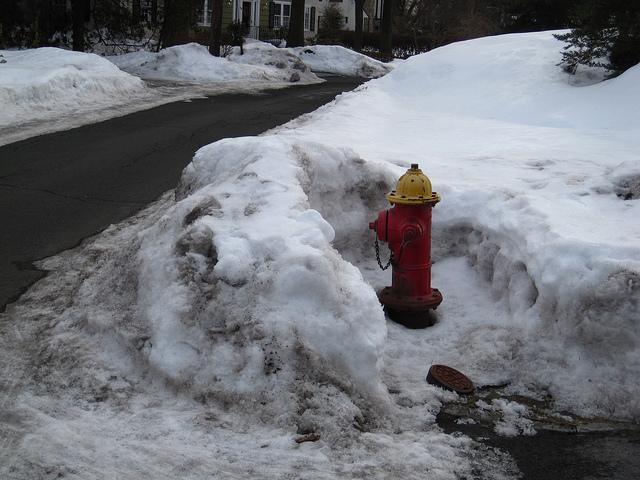Is the snow piled up?
Be succinct. Yes. What is the red object?
Write a very short answer. Fire hydrant. Is the road cleared of snow?
Give a very brief answer. Yes. 